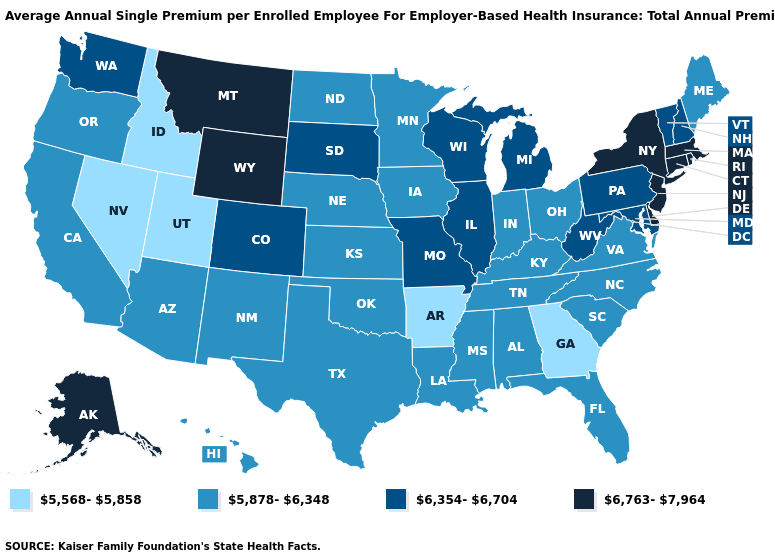What is the value of Oklahoma?
Short answer required. 5,878-6,348. Name the states that have a value in the range 6,763-7,964?
Concise answer only. Alaska, Connecticut, Delaware, Massachusetts, Montana, New Jersey, New York, Rhode Island, Wyoming. Does Idaho have a lower value than Arkansas?
Be succinct. No. Does Indiana have the lowest value in the USA?
Short answer required. No. Among the states that border Tennessee , does Missouri have the highest value?
Be succinct. Yes. Does the first symbol in the legend represent the smallest category?
Concise answer only. Yes. Name the states that have a value in the range 6,763-7,964?
Write a very short answer. Alaska, Connecticut, Delaware, Massachusetts, Montana, New Jersey, New York, Rhode Island, Wyoming. Name the states that have a value in the range 6,763-7,964?
Short answer required. Alaska, Connecticut, Delaware, Massachusetts, Montana, New Jersey, New York, Rhode Island, Wyoming. Name the states that have a value in the range 6,354-6,704?
Concise answer only. Colorado, Illinois, Maryland, Michigan, Missouri, New Hampshire, Pennsylvania, South Dakota, Vermont, Washington, West Virginia, Wisconsin. What is the value of New Mexico?
Keep it brief. 5,878-6,348. What is the value of North Dakota?
Give a very brief answer. 5,878-6,348. What is the value of Georgia?
Answer briefly. 5,568-5,858. Among the states that border South Dakota , does Montana have the lowest value?
Answer briefly. No. Name the states that have a value in the range 6,354-6,704?
Keep it brief. Colorado, Illinois, Maryland, Michigan, Missouri, New Hampshire, Pennsylvania, South Dakota, Vermont, Washington, West Virginia, Wisconsin. What is the value of Illinois?
Concise answer only. 6,354-6,704. 